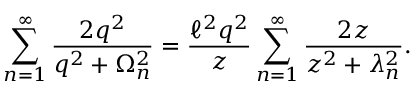Convert formula to latex. <formula><loc_0><loc_0><loc_500><loc_500>\sum _ { n = 1 } ^ { \infty } \frac { 2 q ^ { 2 } } { q ^ { 2 } + \Omega _ { n } ^ { 2 } } = \frac { \ell ^ { 2 } q ^ { 2 } } { z } \sum _ { n = 1 } ^ { \infty } \frac { 2 z } { z ^ { 2 } + \lambda _ { n } ^ { 2 } } .</formula> 